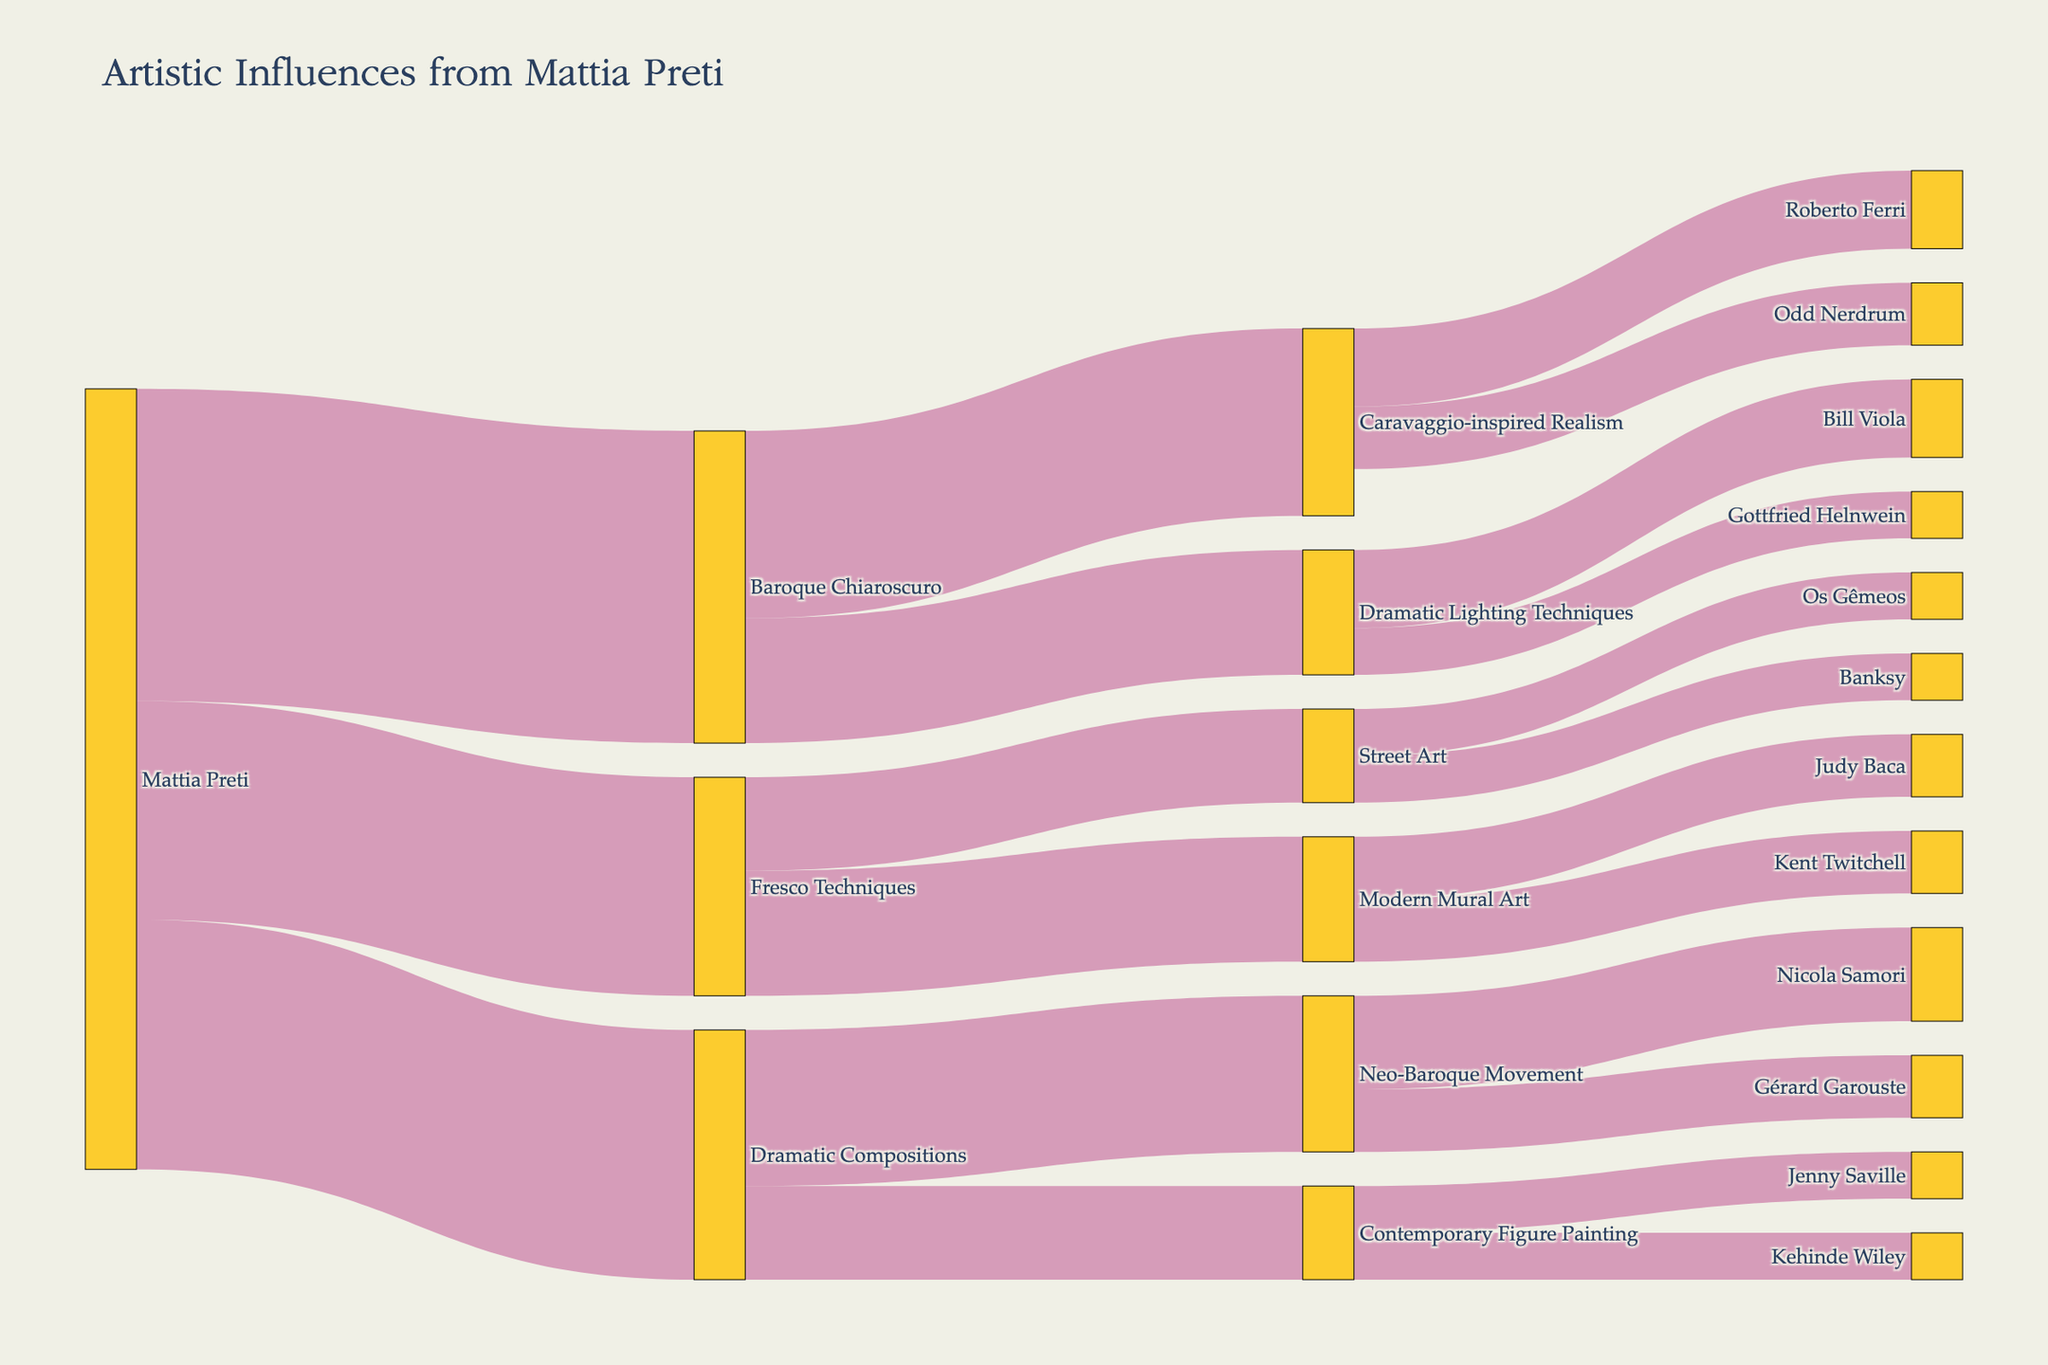Who is the originating artist in the Sankey diagram? The Sankey diagram shows the flow of artistic influences starting from Mattia Preti, indicated as the source node.
Answer: Mattia Preti What is the title of the Sankey diagram? The title of the diagram is displayed at the top of the plot.
Answer: Artistic Influences from Mattia Preti How many nodes does the Sankey diagram contain? Count the total number of individual labels (nodes) in the diagram.
Answer: 16 Which artistic style originating from Mattia Preti has the highest value? Identify the link with the highest value coming directly from Mattia Preti to determine the style.
Answer: Baroque Chiaroscuro What is the total value flowing from Baroque Chiaroscuro to its subsequent styles? Sum the individual values flowing from 'Baroque Chiaroscuro' to 'Caravaggio-inspired Realism' and 'Dramatic Lighting Techniques'.
Answer: 60 + 40 = 100 Which contemporary artist influenced by Caravaggio-inspired Realism has the highest value? Compare the values for contemporary artists under 'Caravaggio-inspired Realism.'
Answer: Roberto Ferri How does the value for Gottfried Helnwein compare to Bill Viola in Dramatic Lighting Techniques? Compare their individual values. Bill Viola has a higher value (25), and Gottfried Helnwein has a value of (15).
Answer: Bill Viola has a higher value How does the total influence value from Mattia Preti to contemporary artists through Fresco Techniques compare to the influence through Dramatic Compositions? Sum the values from Mattia Preti to contemporary artists via both paths and compare. (Fresco Techniques: 40 + 30 = 70) and (Dramatic Compositions: 50 + 30 = 80).
Answer: Dramatic Compositions has a higher total value What is the total influence on Street Art from Mattia Preti? Sum the values flowing into 'Street Art' encompassing both 'Fresco Techniques' branches: influence from Mattia Preti to 'Street Art' via Fresco Techniques.
Answer: 30 Which contemporary Street Artist shown in the diagram has the least total influence from Mattia Preti? Both Banksy and Os Gêmeos are influenced equally from Fresco Techniques to Street Art (15). Identify either as they share the same value.
Answer: Banksy and Os Gêmeos are equal 